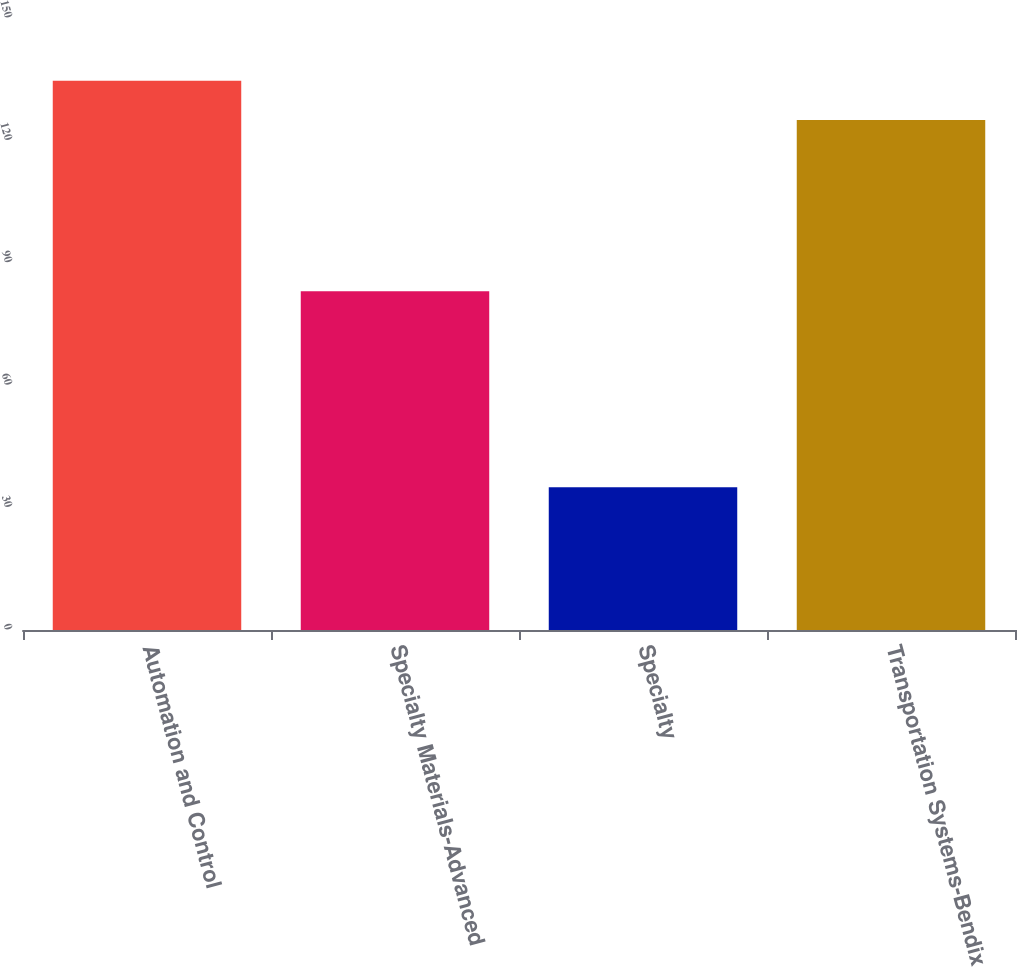Convert chart. <chart><loc_0><loc_0><loc_500><loc_500><bar_chart><fcel>Automation and Control<fcel>Specialty Materials-Advanced<fcel>Specialty<fcel>Transportation Systems-Bendix<nl><fcel>134.6<fcel>83<fcel>35<fcel>125<nl></chart> 